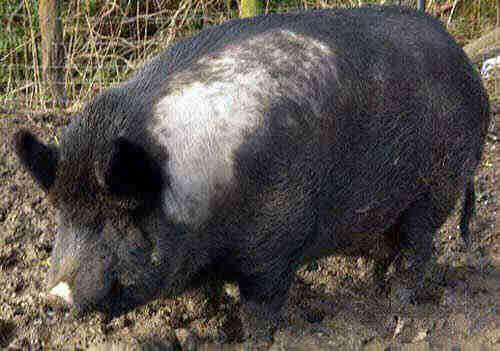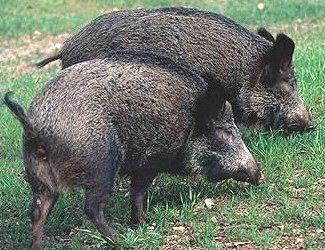The first image is the image on the left, the second image is the image on the right. For the images displayed, is the sentence "At least one image features multiple full grown warthogs." factually correct? Answer yes or no. Yes. 